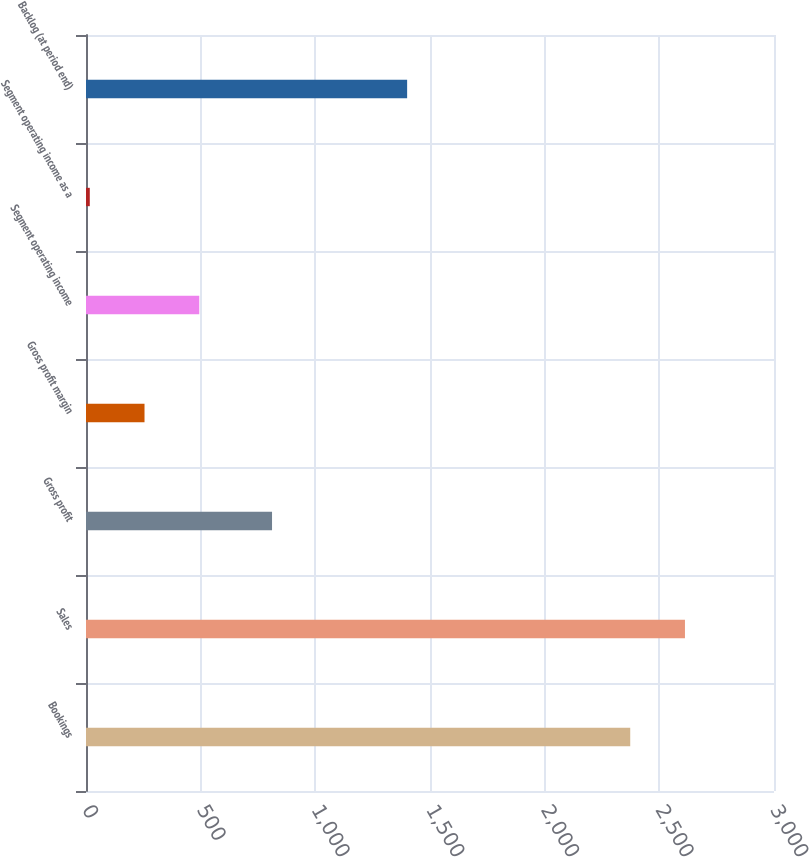Convert chart to OTSL. <chart><loc_0><loc_0><loc_500><loc_500><bar_chart><fcel>Bookings<fcel>Sales<fcel>Gross profit<fcel>Gross profit margin<fcel>Segment operating income<fcel>Segment operating income as a<fcel>Backlog (at period end)<nl><fcel>2373.1<fcel>2611.76<fcel>811.2<fcel>255.16<fcel>493.82<fcel>16.5<fcel>1400.3<nl></chart> 